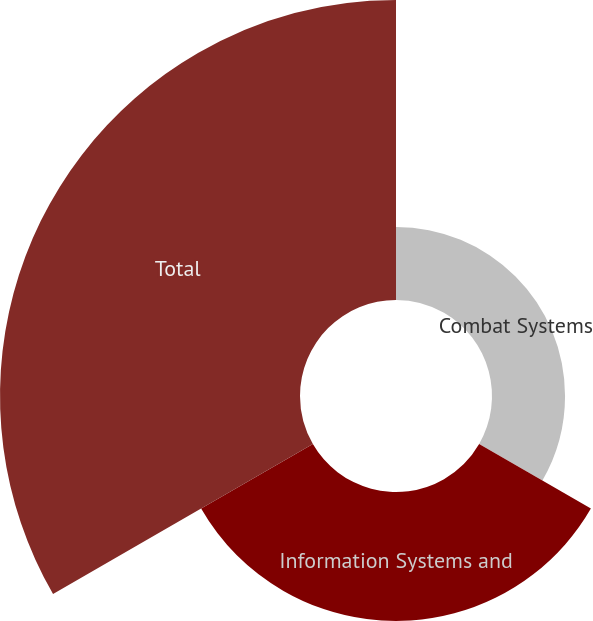Convert chart to OTSL. <chart><loc_0><loc_0><loc_500><loc_500><pie_chart><fcel>Combat Systems<fcel>Information Systems and<fcel>Total<nl><fcel>14.55%<fcel>25.7%<fcel>59.75%<nl></chart> 